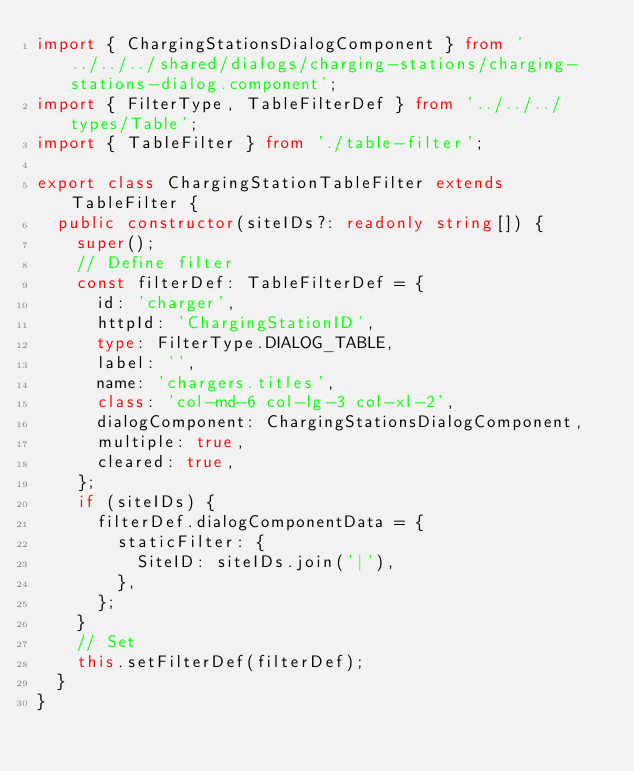Convert code to text. <code><loc_0><loc_0><loc_500><loc_500><_TypeScript_>import { ChargingStationsDialogComponent } from '../../../shared/dialogs/charging-stations/charging-stations-dialog.component';
import { FilterType, TableFilterDef } from '../../../types/Table';
import { TableFilter } from './table-filter';

export class ChargingStationTableFilter extends TableFilter {
  public constructor(siteIDs?: readonly string[]) {
    super();
    // Define filter
    const filterDef: TableFilterDef = {
      id: 'charger',
      httpId: 'ChargingStationID',
      type: FilterType.DIALOG_TABLE,
      label: '',
      name: 'chargers.titles',
      class: 'col-md-6 col-lg-3 col-xl-2',
      dialogComponent: ChargingStationsDialogComponent,
      multiple: true,
      cleared: true,
    };
    if (siteIDs) {
      filterDef.dialogComponentData = {
        staticFilter: {
          SiteID: siteIDs.join('|'),
        },
      };
    }
    // Set
    this.setFilterDef(filterDef);
  }
}
</code> 